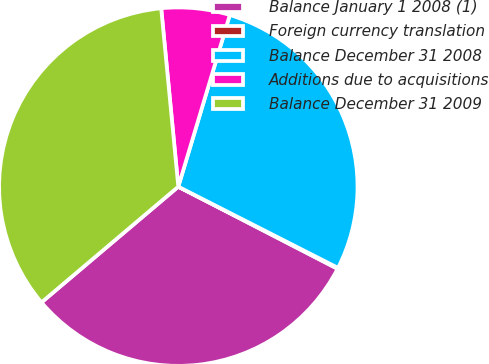Convert chart. <chart><loc_0><loc_0><loc_500><loc_500><pie_chart><fcel>Balance January 1 2008 (1)<fcel>Foreign currency translation<fcel>Balance December 31 2008<fcel>Additions due to acquisitions<fcel>Balance December 31 2009<nl><fcel>31.25%<fcel>0.09%<fcel>27.85%<fcel>6.16%<fcel>34.65%<nl></chart> 